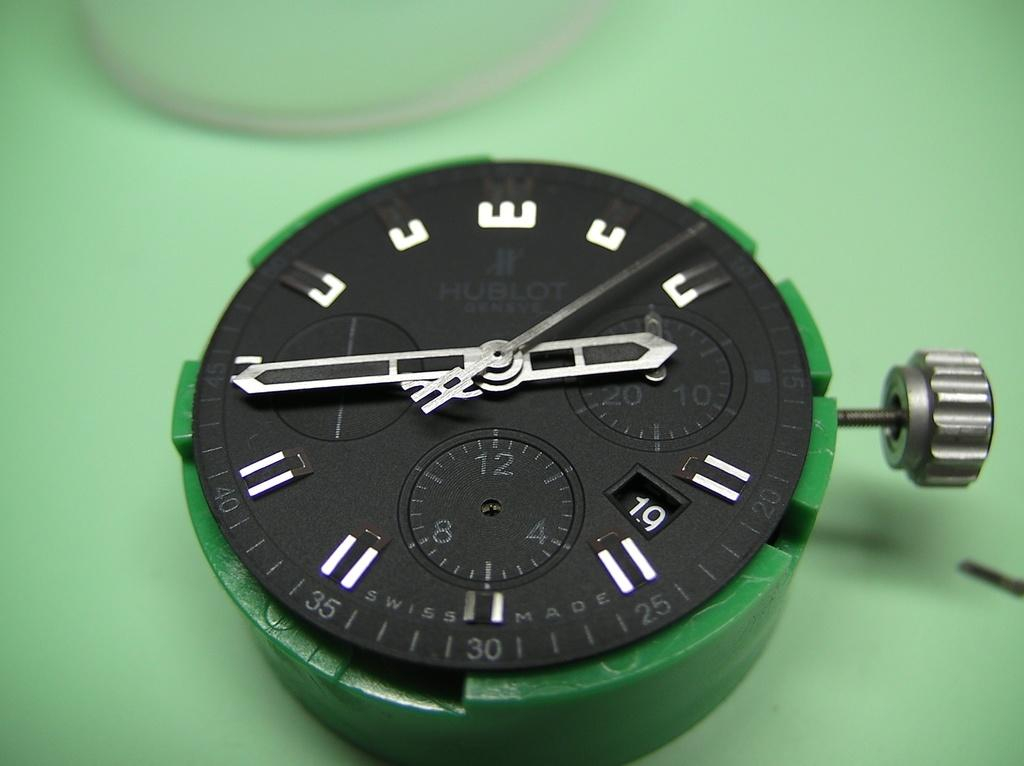<image>
Give a short and clear explanation of the subsequent image. A watch face that has the minutes labeled along the edges, with 30 at the bottom. 